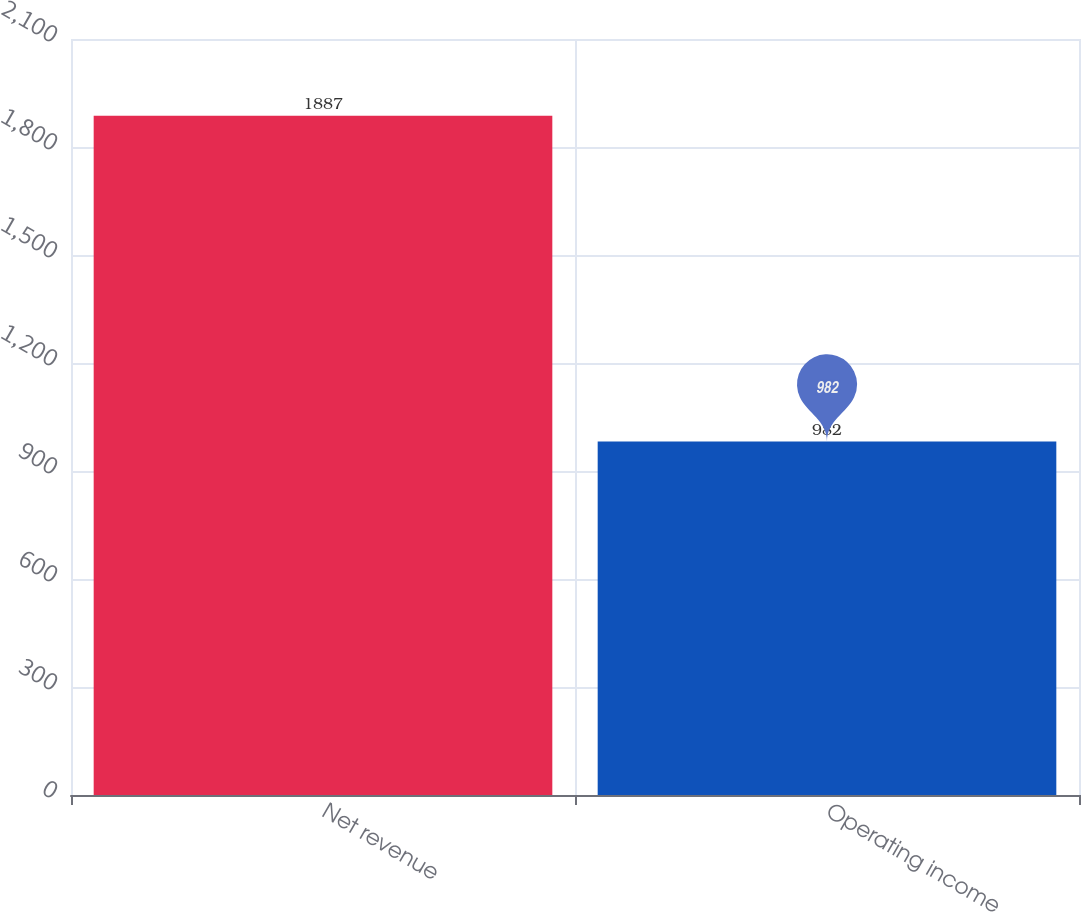Convert chart to OTSL. <chart><loc_0><loc_0><loc_500><loc_500><bar_chart><fcel>Net revenue<fcel>Operating income<nl><fcel>1887<fcel>982<nl></chart> 